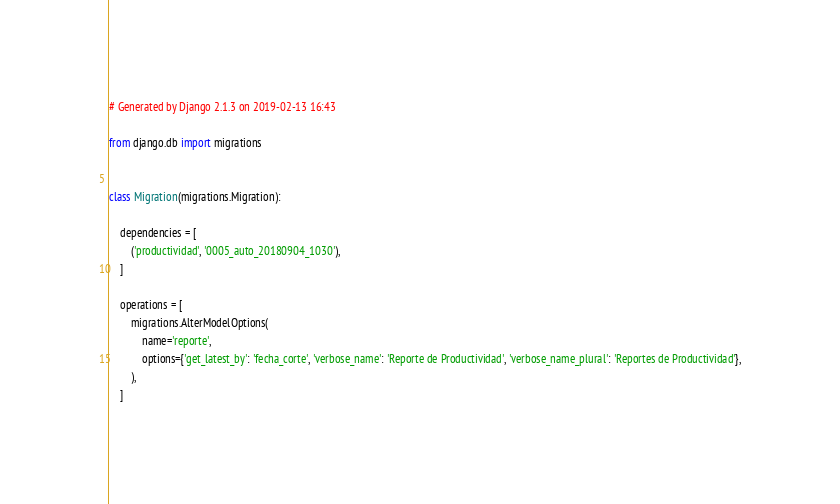Convert code to text. <code><loc_0><loc_0><loc_500><loc_500><_Python_># Generated by Django 2.1.3 on 2019-02-13 16:43

from django.db import migrations


class Migration(migrations.Migration):

    dependencies = [
        ('productividad', '0005_auto_20180904_1030'),
    ]

    operations = [
        migrations.AlterModelOptions(
            name='reporte',
            options={'get_latest_by': 'fecha_corte', 'verbose_name': 'Reporte de Productividad', 'verbose_name_plural': 'Reportes de Productividad'},
        ),
    ]
</code> 